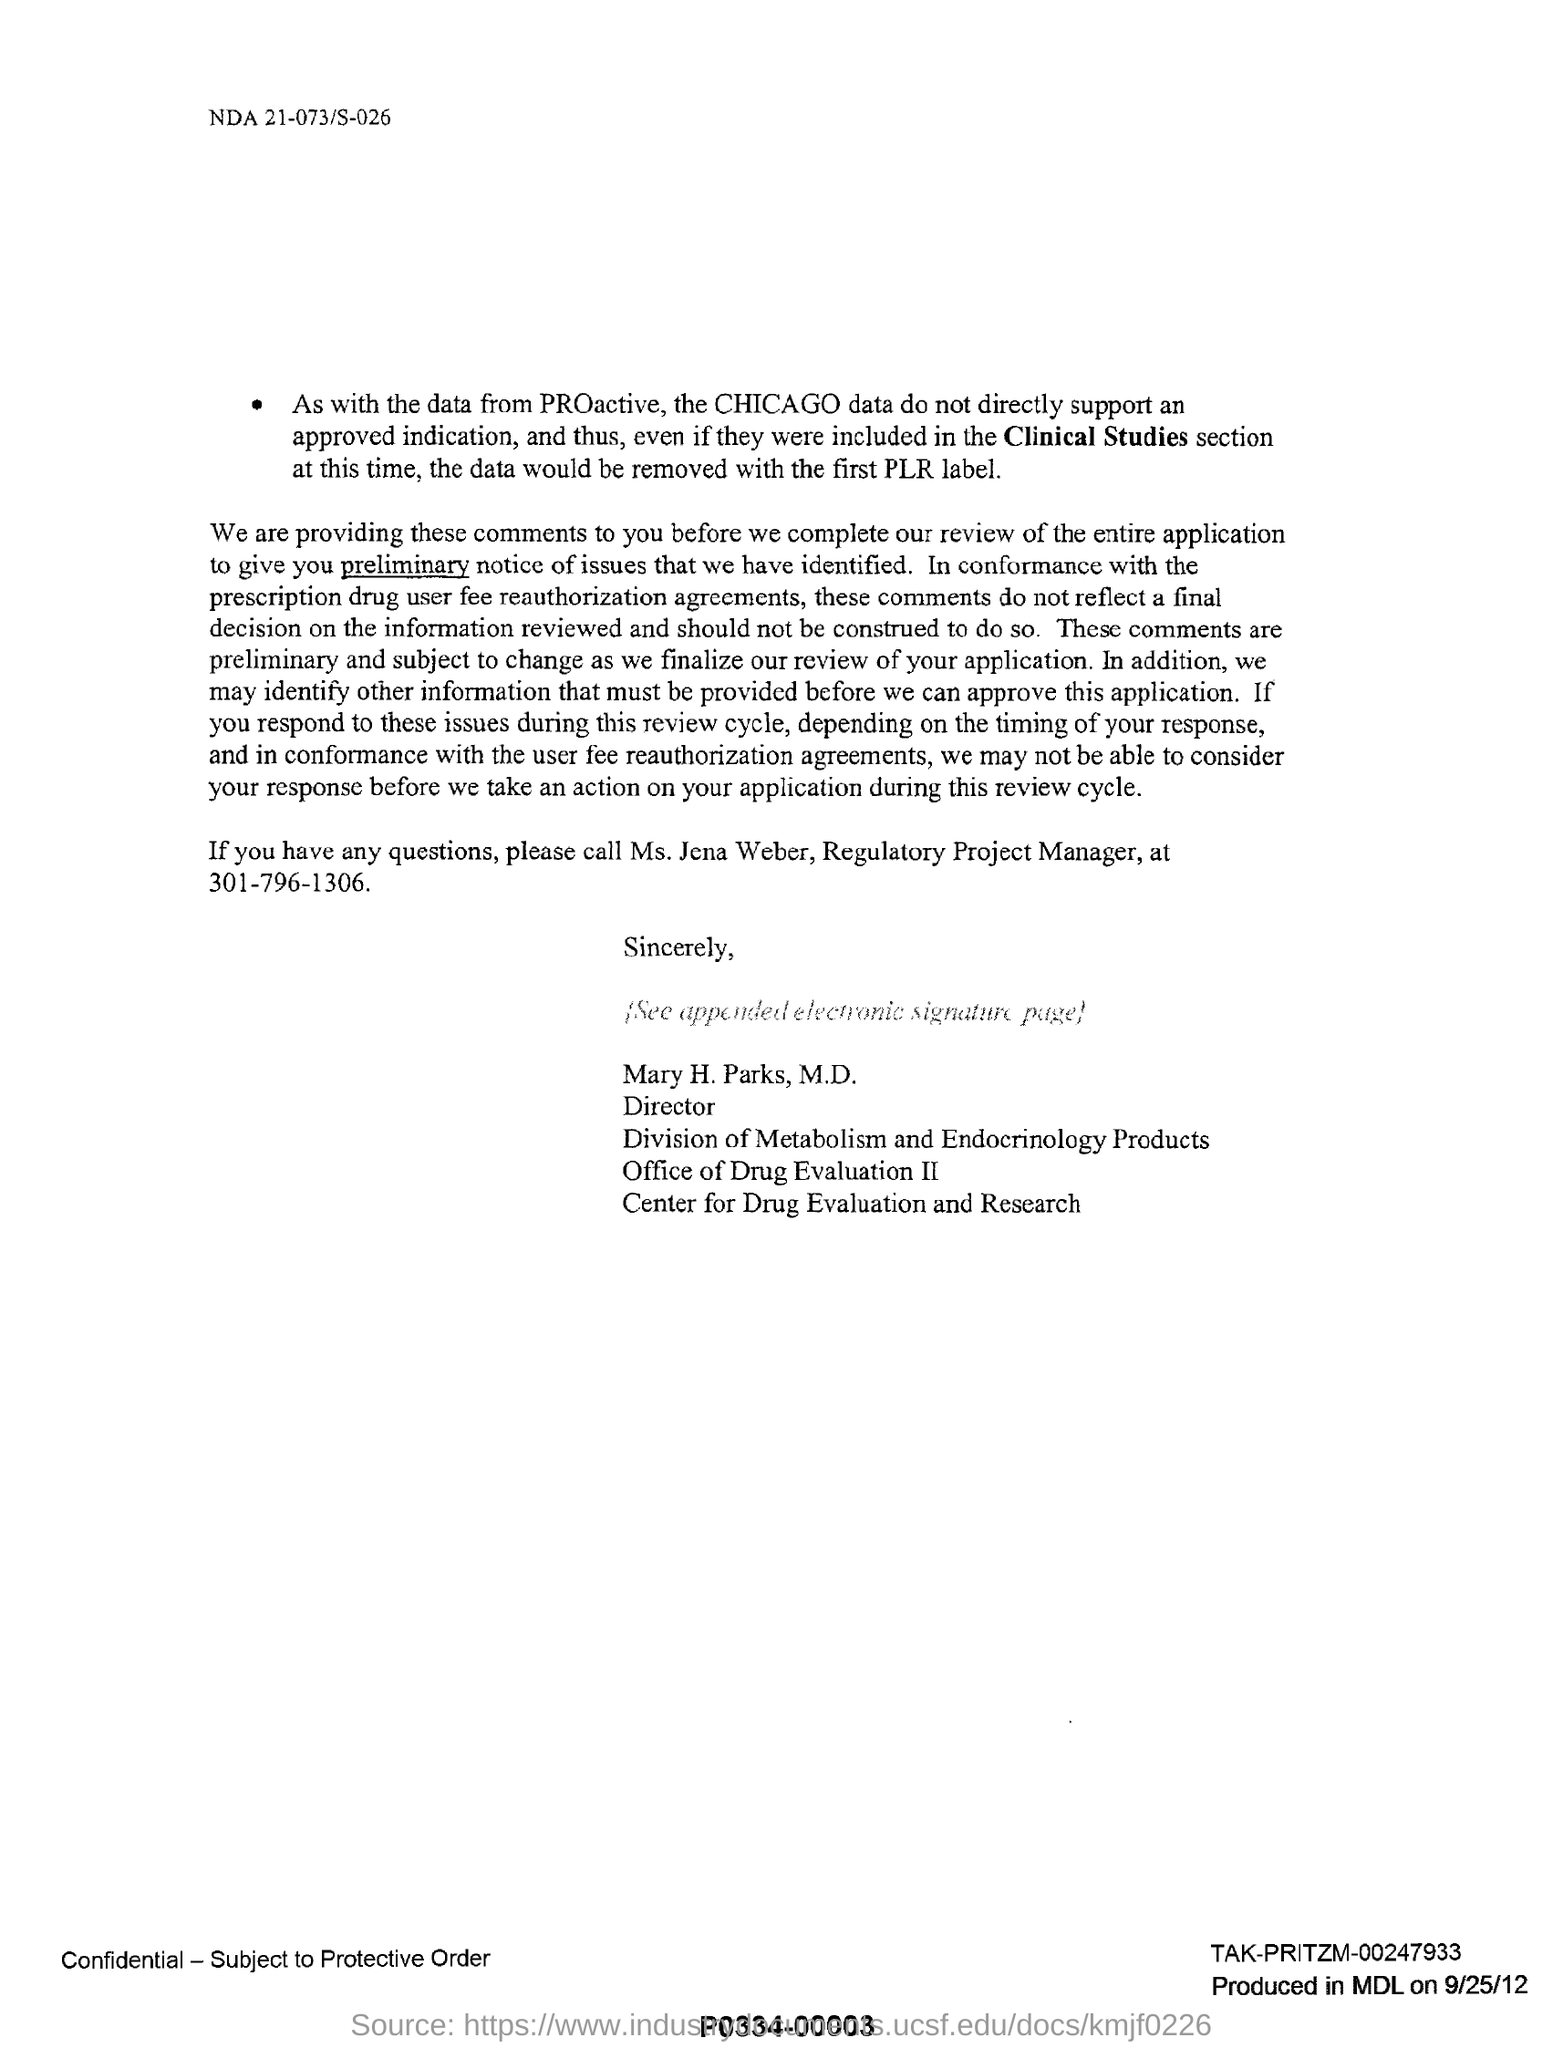Mention a couple of crucial points in this snapshot. Ms. Jena Weber holds the position of Regulatory Project Manager. Mary H. Parks, M.D. holds the designation of Director. The contact number of Ms. Jena Weber is 301-796-1306. Mary H. Parks, M.D., has signed this document. 